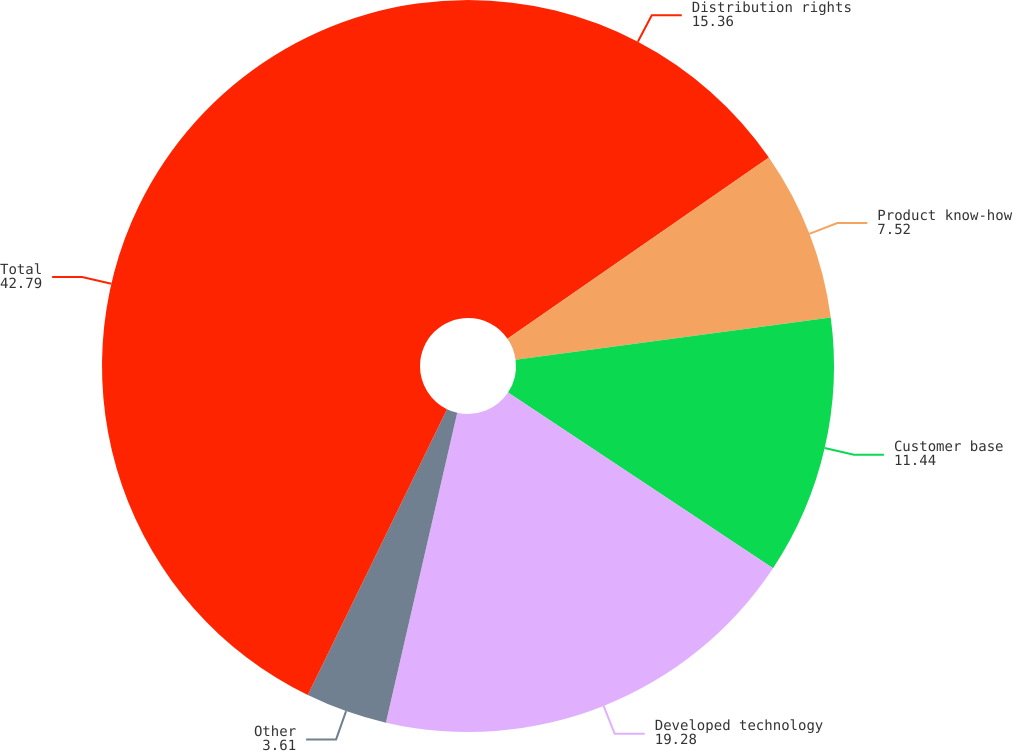Convert chart to OTSL. <chart><loc_0><loc_0><loc_500><loc_500><pie_chart><fcel>Distribution rights<fcel>Product know-how<fcel>Customer base<fcel>Developed technology<fcel>Other<fcel>Total<nl><fcel>15.36%<fcel>7.52%<fcel>11.44%<fcel>19.28%<fcel>3.61%<fcel>42.79%<nl></chart> 